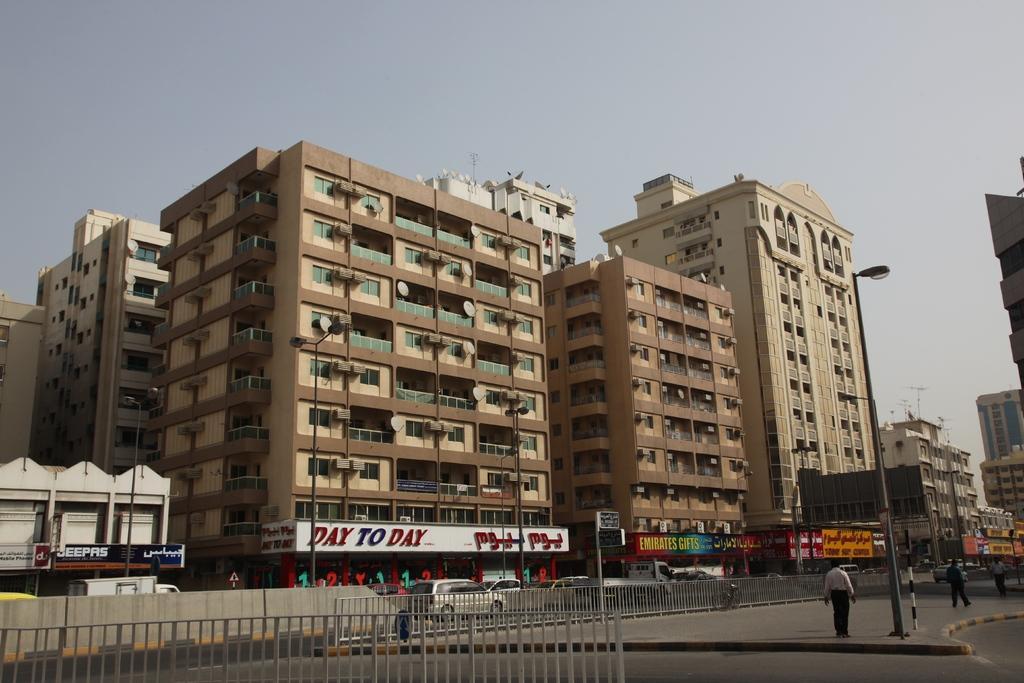Please provide a concise description of this image. In this image there are people walking on the pavement having street lights. Bottom of the image there is a fence. Behind there are vehicles on the road. Background there are buildings. Top of the image there is sky. 